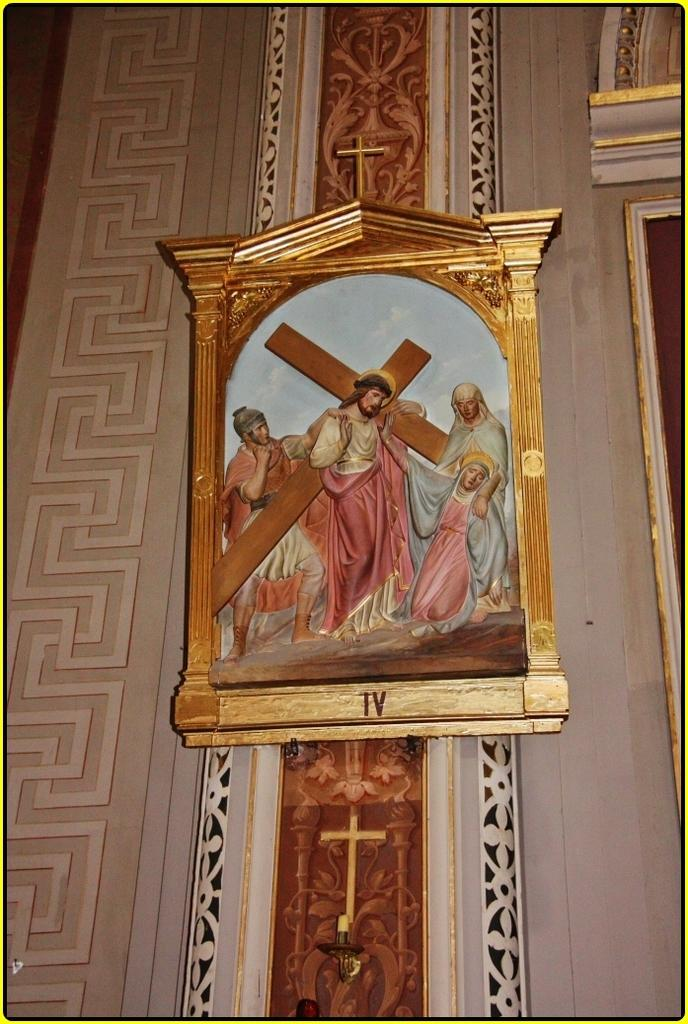<image>
Provide a brief description of the given image. A painting of Jesus carrying a cross is marked "IV." 